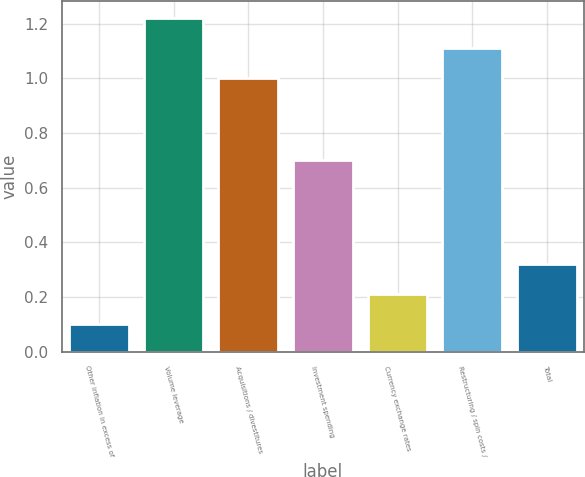<chart> <loc_0><loc_0><loc_500><loc_500><bar_chart><fcel>Other inflation in excess of<fcel>Volume leverage<fcel>Acquisitions / divestitures<fcel>Investment spending<fcel>Currency exchange rates<fcel>Restructuring / spin costs /<fcel>Total<nl><fcel>0.1<fcel>1.22<fcel>1<fcel>0.7<fcel>0.21<fcel>1.11<fcel>0.32<nl></chart> 